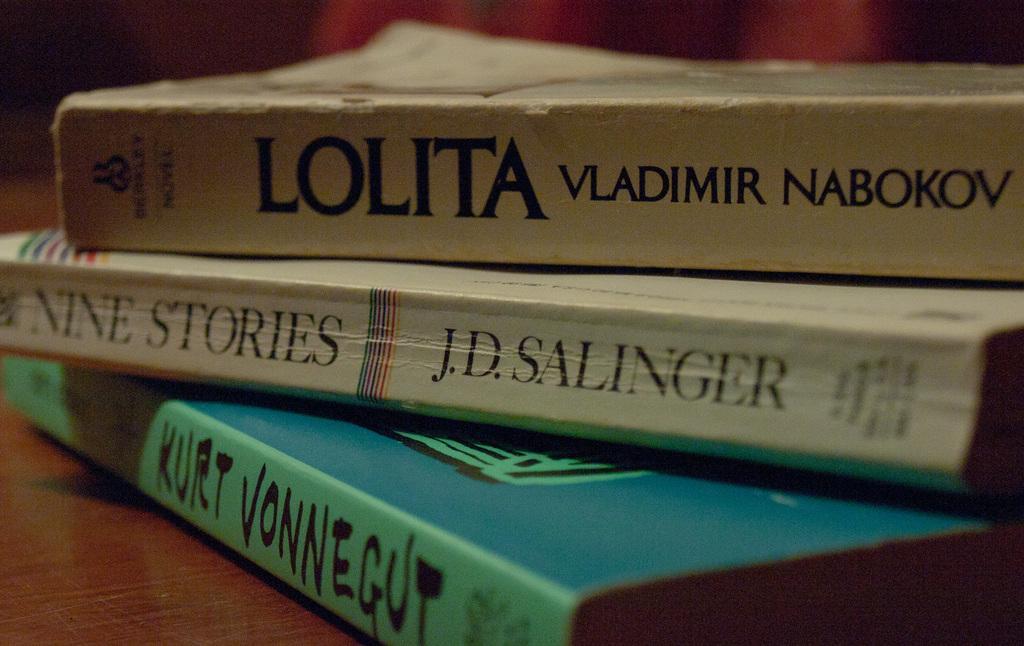Please provide a concise description of this image. There are three books on the table. The bottom book is in green color, second book is in white color and the first book is in grey color. 